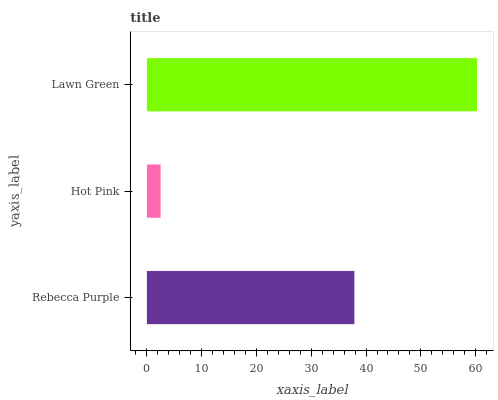Is Hot Pink the minimum?
Answer yes or no. Yes. Is Lawn Green the maximum?
Answer yes or no. Yes. Is Lawn Green the minimum?
Answer yes or no. No. Is Hot Pink the maximum?
Answer yes or no. No. Is Lawn Green greater than Hot Pink?
Answer yes or no. Yes. Is Hot Pink less than Lawn Green?
Answer yes or no. Yes. Is Hot Pink greater than Lawn Green?
Answer yes or no. No. Is Lawn Green less than Hot Pink?
Answer yes or no. No. Is Rebecca Purple the high median?
Answer yes or no. Yes. Is Rebecca Purple the low median?
Answer yes or no. Yes. Is Lawn Green the high median?
Answer yes or no. No. Is Hot Pink the low median?
Answer yes or no. No. 